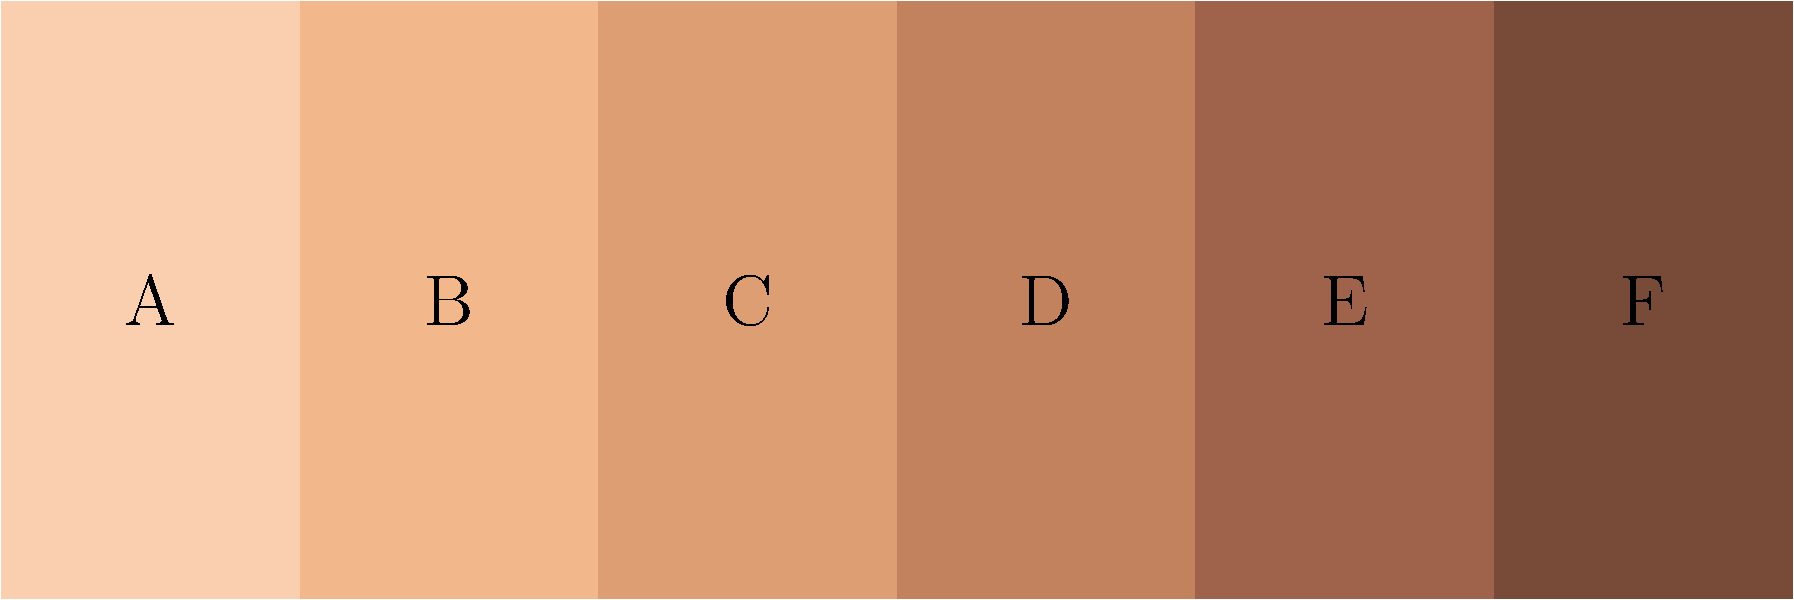In the color palette shown above, which letter corresponds to the skin tone typically associated with individuals of South Asian descent? To answer this question, we need to consider the typical range of skin tones found in South Asian populations:

1. South Asian skin tones generally fall in the medium to dark range of the spectrum.
2. The palette shows a progression from light to dark skin tones, labeled A through F.
3. We can eliminate A and B as they represent very light skin tones.
4. F represents a very dark skin tone, which is less common in South Asian populations.
5. Among C, D, and E, we need to choose the most representative tone.
6. C is still relatively light, while E is quite dark for the average South Asian skin tone.
7. D represents a medium brown tone, which is most commonly associated with South Asian skin.

Therefore, the skin tone typically associated with individuals of South Asian descent in this palette would be D.
Answer: D 